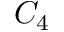<formula> <loc_0><loc_0><loc_500><loc_500>C _ { 4 }</formula> 